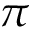<formula> <loc_0><loc_0><loc_500><loc_500>\pi</formula> 